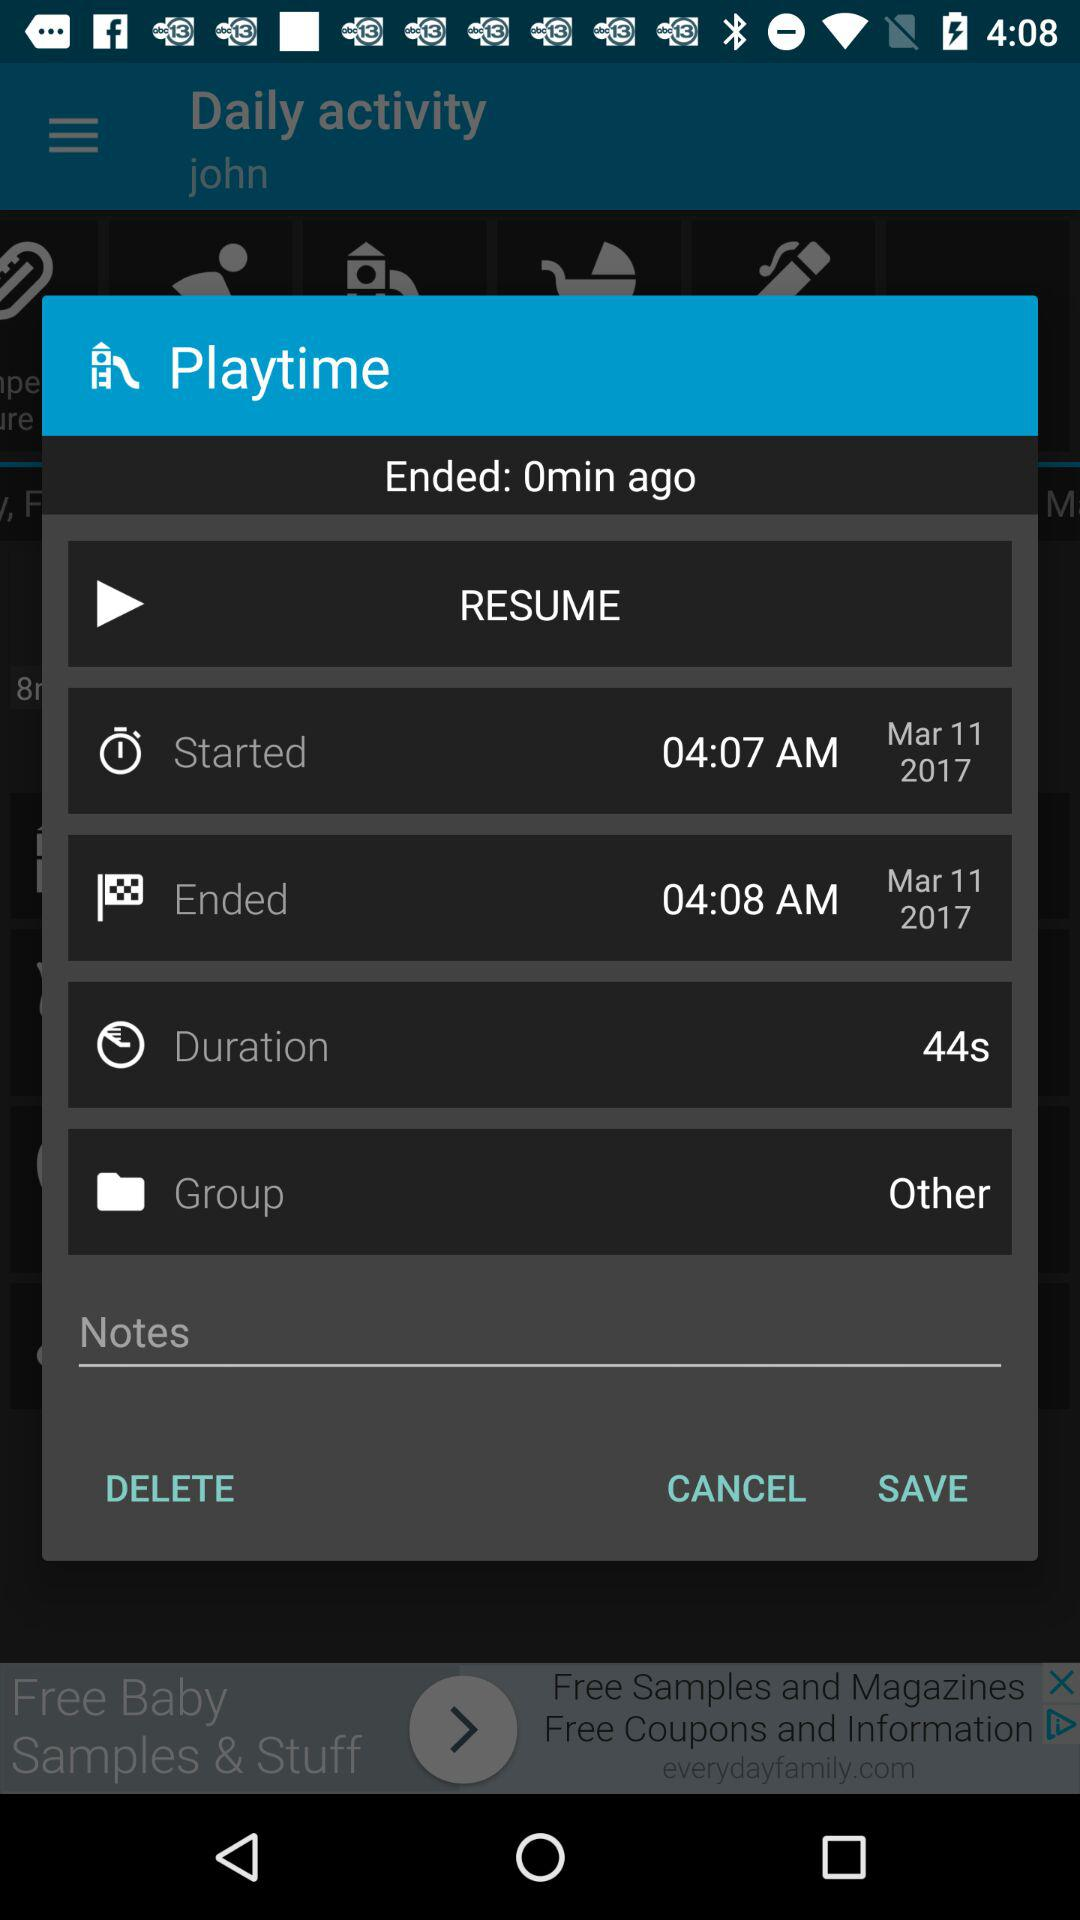How long is the duration of the recording?
Answer the question using a single word or phrase. 44s 